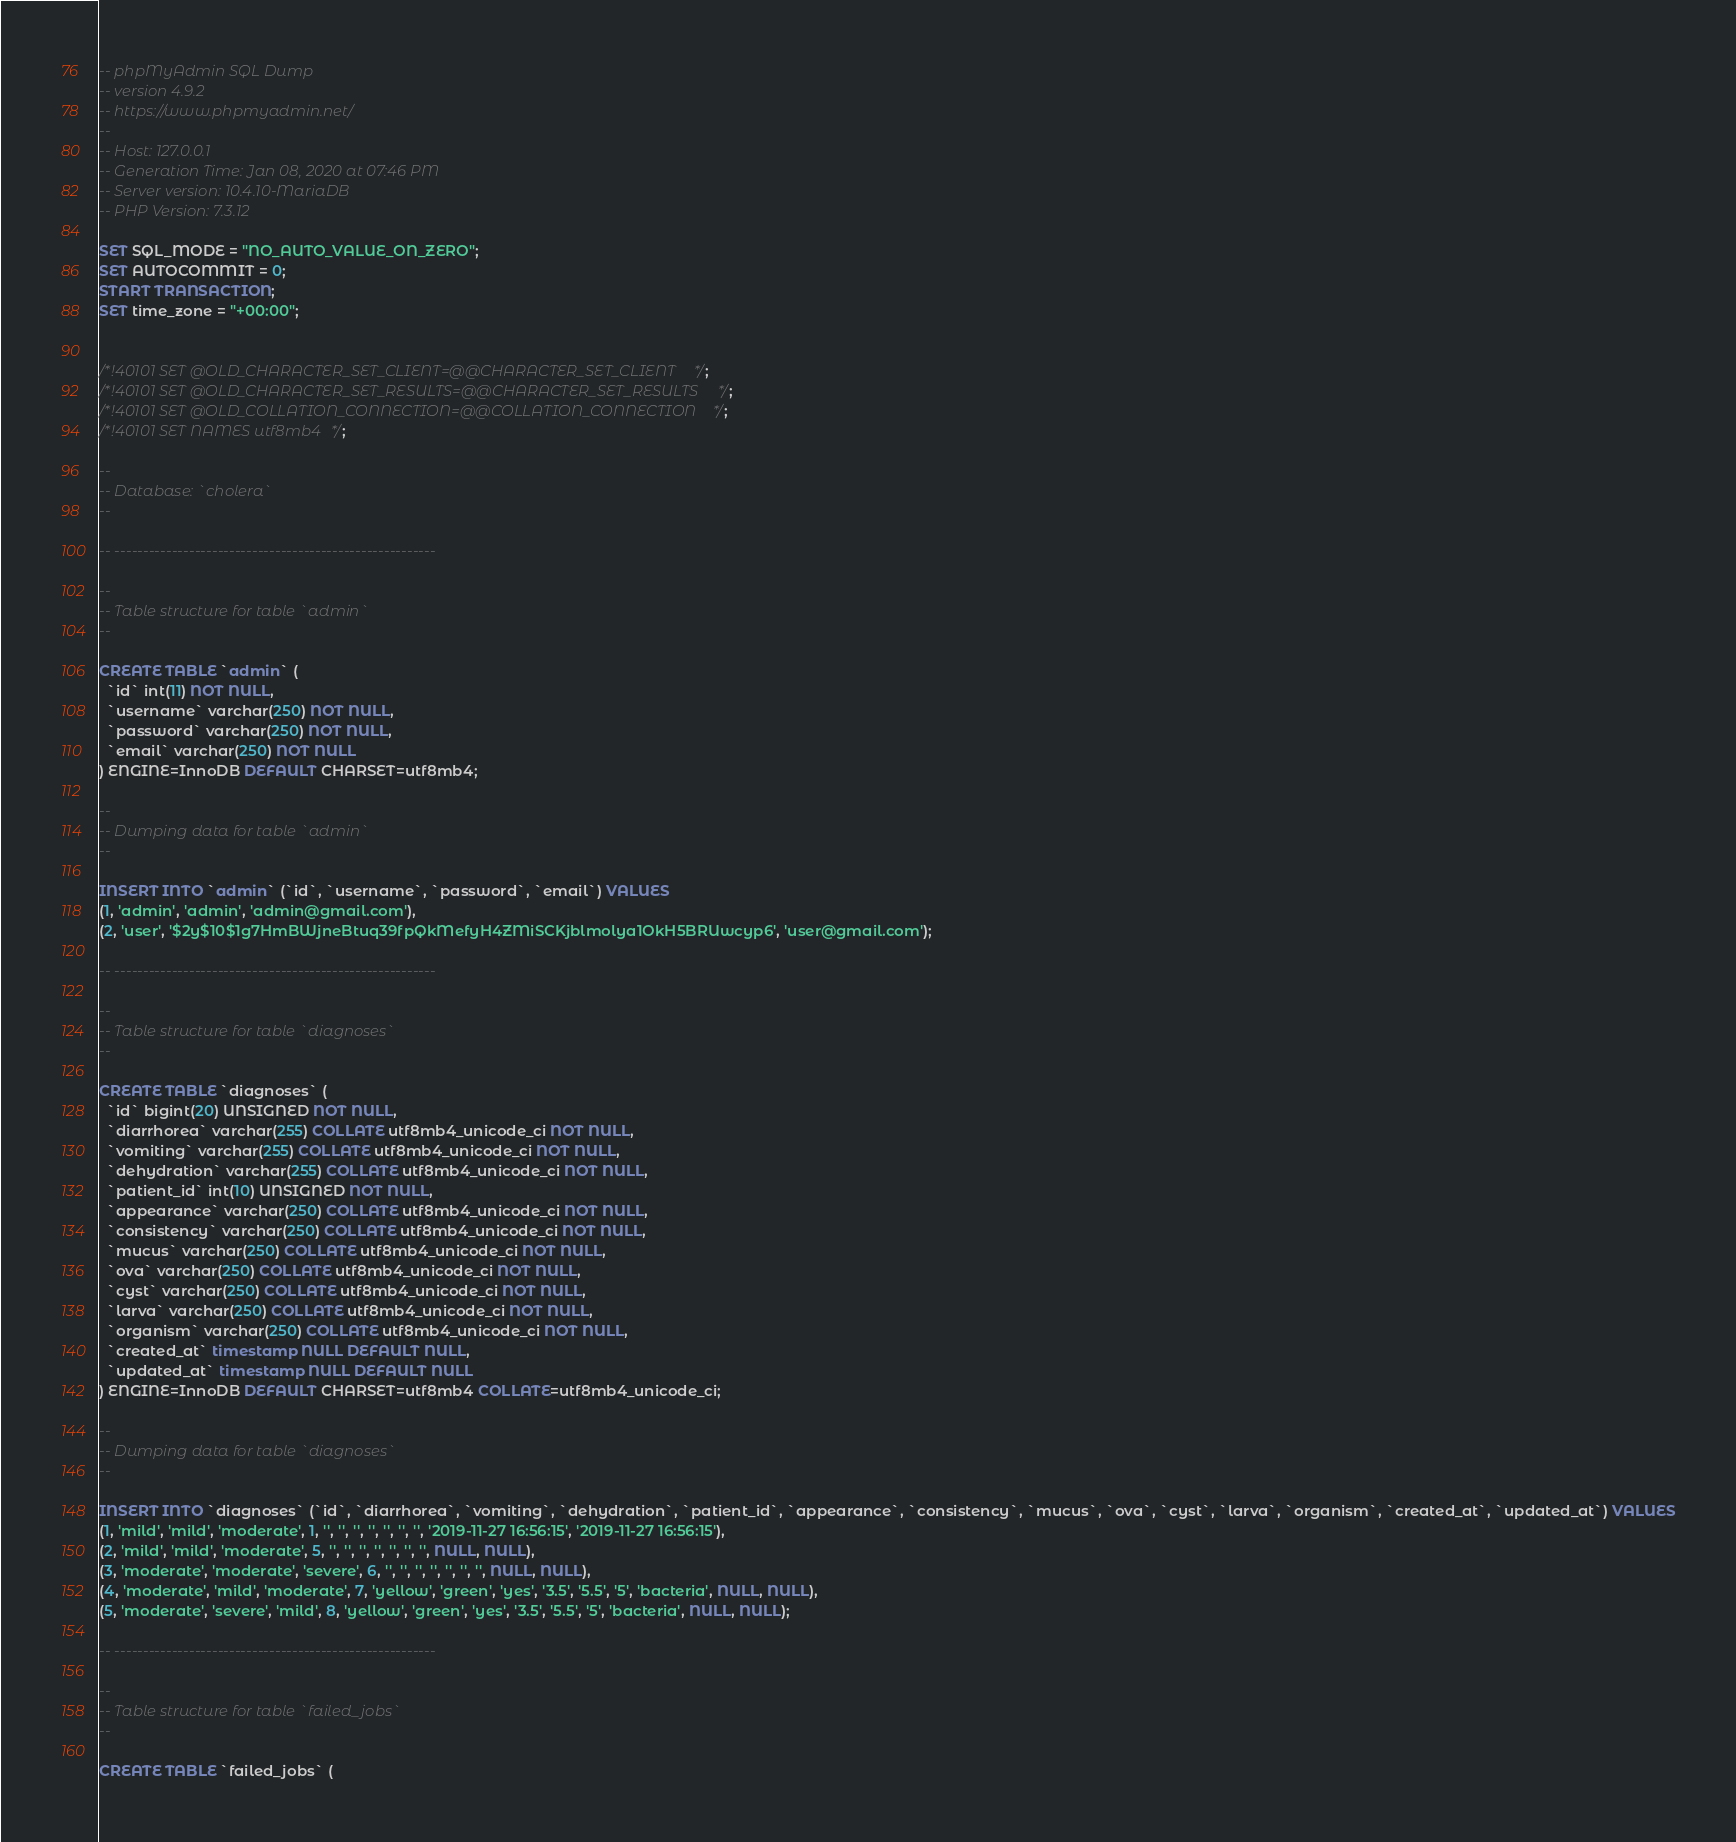Convert code to text. <code><loc_0><loc_0><loc_500><loc_500><_SQL_>-- phpMyAdmin SQL Dump
-- version 4.9.2
-- https://www.phpmyadmin.net/
--
-- Host: 127.0.0.1
-- Generation Time: Jan 08, 2020 at 07:46 PM
-- Server version: 10.4.10-MariaDB
-- PHP Version: 7.3.12

SET SQL_MODE = "NO_AUTO_VALUE_ON_ZERO";
SET AUTOCOMMIT = 0;
START TRANSACTION;
SET time_zone = "+00:00";


/*!40101 SET @OLD_CHARACTER_SET_CLIENT=@@CHARACTER_SET_CLIENT */;
/*!40101 SET @OLD_CHARACTER_SET_RESULTS=@@CHARACTER_SET_RESULTS */;
/*!40101 SET @OLD_COLLATION_CONNECTION=@@COLLATION_CONNECTION */;
/*!40101 SET NAMES utf8mb4 */;

--
-- Database: `cholera`
--

-- --------------------------------------------------------

--
-- Table structure for table `admin`
--

CREATE TABLE `admin` (
  `id` int(11) NOT NULL,
  `username` varchar(250) NOT NULL,
  `password` varchar(250) NOT NULL,
  `email` varchar(250) NOT NULL
) ENGINE=InnoDB DEFAULT CHARSET=utf8mb4;

--
-- Dumping data for table `admin`
--

INSERT INTO `admin` (`id`, `username`, `password`, `email`) VALUES
(1, 'admin', 'admin', 'admin@gmail.com'),
(2, 'user', '$2y$10$1g7HmBWjneBtuq39fpQkMefyH4ZMiSCKjblmolya1OkH5BRUwcyp6', 'user@gmail.com');

-- --------------------------------------------------------

--
-- Table structure for table `diagnoses`
--

CREATE TABLE `diagnoses` (
  `id` bigint(20) UNSIGNED NOT NULL,
  `diarrhorea` varchar(255) COLLATE utf8mb4_unicode_ci NOT NULL,
  `vomiting` varchar(255) COLLATE utf8mb4_unicode_ci NOT NULL,
  `dehydration` varchar(255) COLLATE utf8mb4_unicode_ci NOT NULL,
  `patient_id` int(10) UNSIGNED NOT NULL,
  `appearance` varchar(250) COLLATE utf8mb4_unicode_ci NOT NULL,
  `consistency` varchar(250) COLLATE utf8mb4_unicode_ci NOT NULL,
  `mucus` varchar(250) COLLATE utf8mb4_unicode_ci NOT NULL,
  `ova` varchar(250) COLLATE utf8mb4_unicode_ci NOT NULL,
  `cyst` varchar(250) COLLATE utf8mb4_unicode_ci NOT NULL,
  `larva` varchar(250) COLLATE utf8mb4_unicode_ci NOT NULL,
  `organism` varchar(250) COLLATE utf8mb4_unicode_ci NOT NULL,
  `created_at` timestamp NULL DEFAULT NULL,
  `updated_at` timestamp NULL DEFAULT NULL
) ENGINE=InnoDB DEFAULT CHARSET=utf8mb4 COLLATE=utf8mb4_unicode_ci;

--
-- Dumping data for table `diagnoses`
--

INSERT INTO `diagnoses` (`id`, `diarrhorea`, `vomiting`, `dehydration`, `patient_id`, `appearance`, `consistency`, `mucus`, `ova`, `cyst`, `larva`, `organism`, `created_at`, `updated_at`) VALUES
(1, 'mild', 'mild', 'moderate', 1, '', '', '', '', '', '', '', '2019-11-27 16:56:15', '2019-11-27 16:56:15'),
(2, 'mild', 'mild', 'moderate', 5, '', '', '', '', '', '', '', NULL, NULL),
(3, 'moderate', 'moderate', 'severe', 6, '', '', '', '', '', '', '', NULL, NULL),
(4, 'moderate', 'mild', 'moderate', 7, 'yellow', 'green', 'yes', '3.5', '5.5', '5', 'bacteria', NULL, NULL),
(5, 'moderate', 'severe', 'mild', 8, 'yellow', 'green', 'yes', '3.5', '5.5', '5', 'bacteria', NULL, NULL);

-- --------------------------------------------------------

--
-- Table structure for table `failed_jobs`
--

CREATE TABLE `failed_jobs` (</code> 